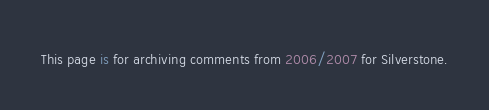<code> <loc_0><loc_0><loc_500><loc_500><_FORTRAN_>This page is for archiving comments from 2006/2007 for Silverstone.
</code> 